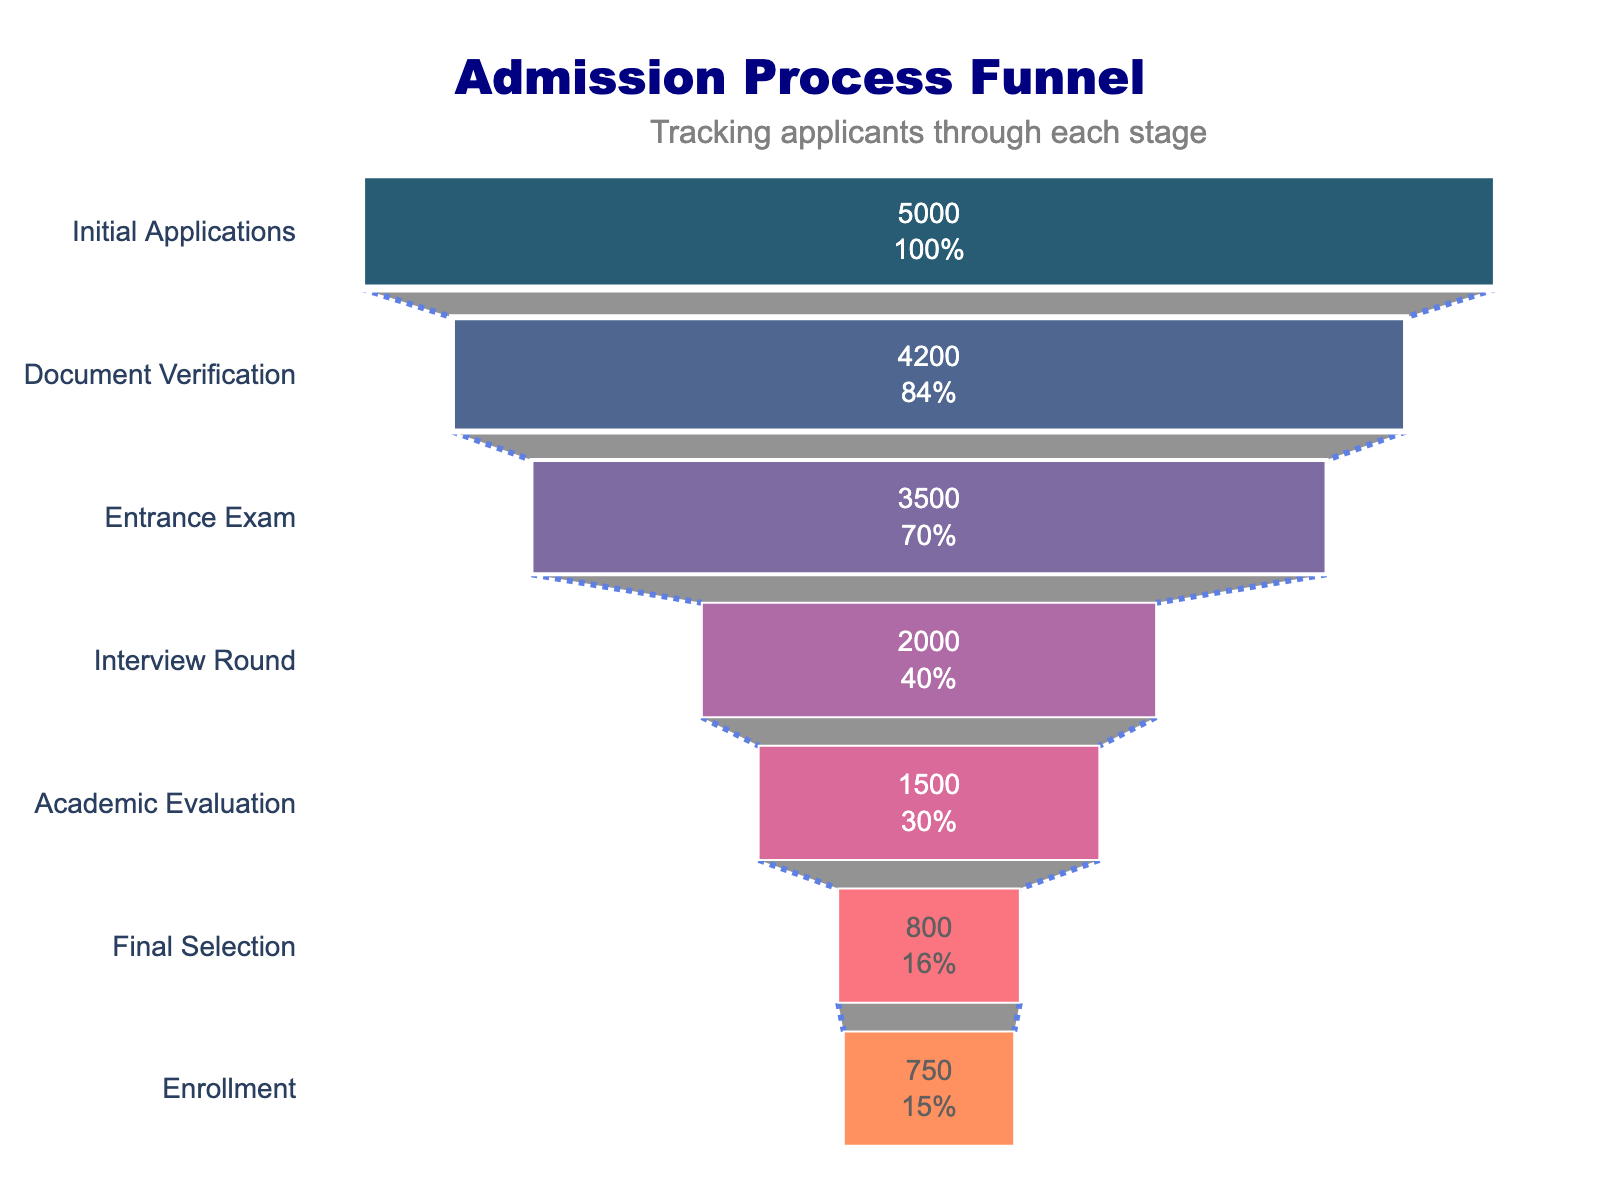how many stages are there in the admission process? Count the number of distinct stages shown on the Y-axis of the funnel chart.
Answer: 7 What is the title of the funnel chart? Read the title text displayed at the top of the funnel chart. It describes the chart's content.
Answer: Admission Process Funnel What percentage of applicants proceed from the initial application to document verification? The funnel chart shows the percentage of initial applicants at each stage. Document Verification is the second stage, so note the percentage displayed there.
Answer: 84% How much does the number of applicants drop from the entrance exam to the interview round? Subtract the number of applicants in the Interview Round (2000) from those in the Entrance Exam (3500).
Answer: 1500 Which stage has the lowest number of applicants? Identify the stage at the bottom of the funnel chart with the smallest value on the X-axis (Enrollment).
Answer: Enrollment What is the difference in the number of applicants between academic evaluation and final selection? Subtract the number of applicants in Final Selection (800) from those in Academic Evaluation (1500).
Answer: 700 How many applicants passed the document verification stage but didn't get to the entrance exam stage? Subtract the number of applicants in the Entrance Exam stage (3500) from those in the Document Verification stage (4200).
Answer: 700 What percentage of the initial applicants make it to the enrollment stage? Identify the percentage of initial applicants shown in the Enrollment stage on the chart.
Answer: 15% Compare the number of applicants between the interview round and academic evaluation. The number of applicants in the Interview Round is 2000, and in Academic Evaluation is 1500.
Answer: Interview Round has more By how much does the number of applicants decrease from the Final Selection to Enrollment? Subtract the number of applicants in Enrollment (750) from those in Final Selection (800).
Answer: 50 